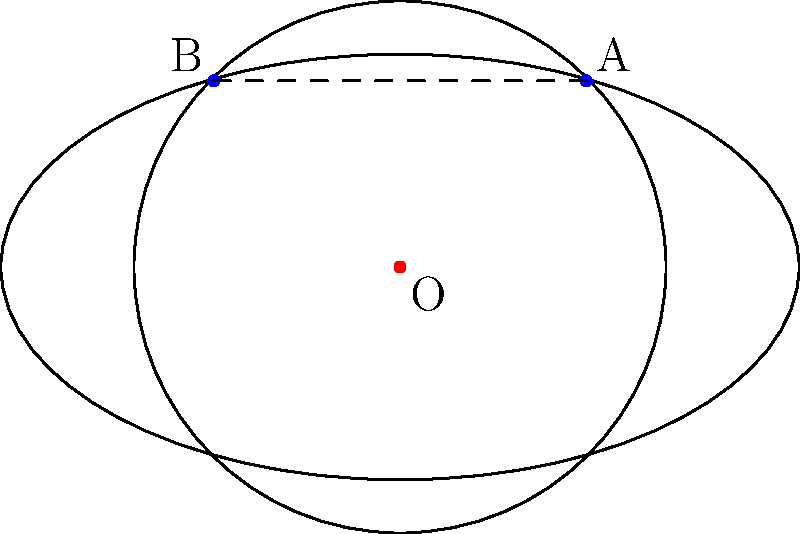In the projective plane model of elliptic geometry shown above, a circle is represented by an ellipse. Points A and B appear to be on the circle. However, in elliptic geometry, what is the true nature of the line segment AB in relation to the circle? To understand this, let's follow these steps:

1. In Euclidean geometry, a line segment connecting two points on a circle would be a chord that lies entirely inside the circle.

2. However, in elliptic geometry, straight lines are represented as great circles on a sphere, which project to ellipses on the projective plane.

3. In this model, the "line" connecting A and B is actually part of an ellipse that intersects the given circle at these two points.

4. In elliptic geometry, any two distinct points determine a unique line, and any line intersects any circle in exactly two points (which may coincide).

5. Therefore, the line AB must extend beyond the visible segment, wrapping around the projective plane and intersecting the circle again at the antipodal points of A and B.

6. This means that in elliptic geometry, the line AB actually intersects the circle at four points in total: A, B, and their antipodal points.

7. Consequently, the line AB is not contained within the circle, but rather passes through it, extending infinitely in both directions on the surface of the projective plane.

This concept illustrates how our intuition from Euclidean geometry can be misleading when applied to non-Euclidean geometries, emphasizing the importance of understanding different geometric models in conflict resolution and peace-building efforts.
Answer: The line AB intersects the circle at four points and is not contained within it. 